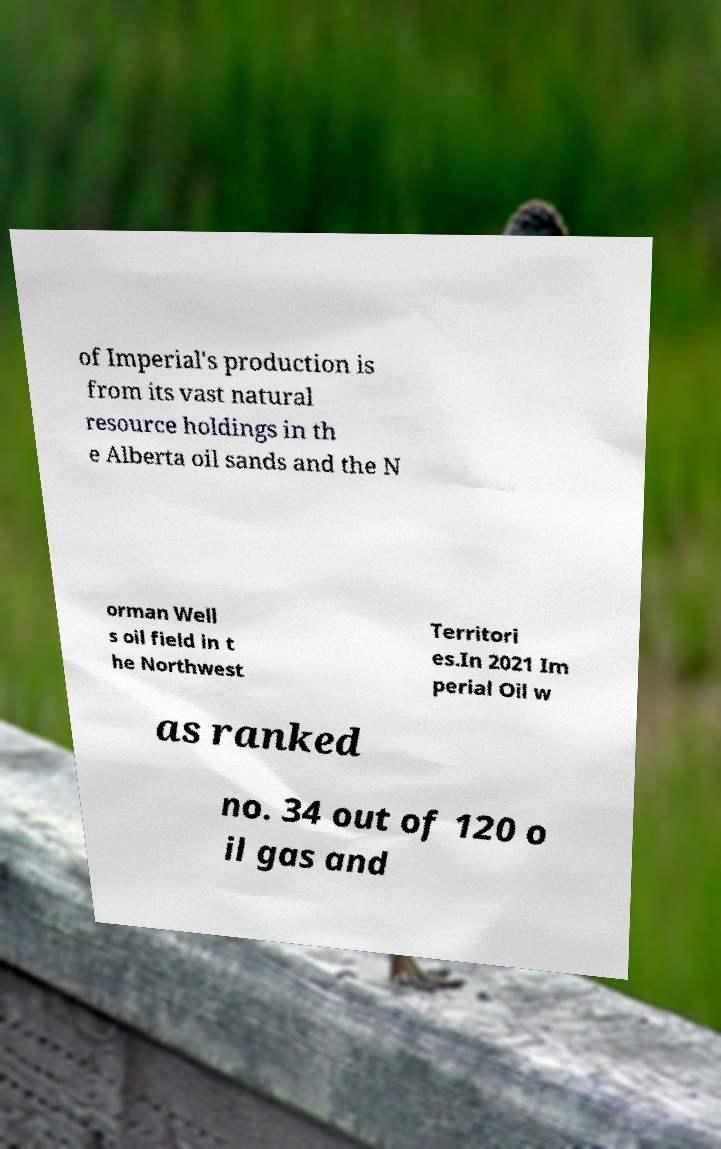Could you extract and type out the text from this image? of Imperial's production is from its vast natural resource holdings in th e Alberta oil sands and the N orman Well s oil field in t he Northwest Territori es.In 2021 Im perial Oil w as ranked no. 34 out of 120 o il gas and 